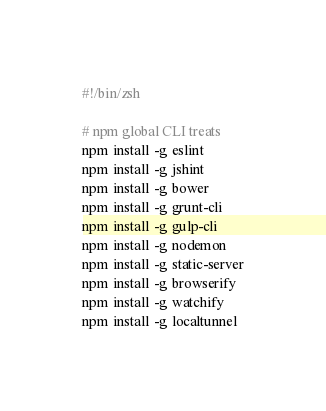Convert code to text. <code><loc_0><loc_0><loc_500><loc_500><_Bash_>#!/bin/zsh

# npm global CLI treats
npm install -g eslint
npm install -g jshint
npm install -g bower
npm install -g grunt-cli
npm install -g gulp-cli
npm install -g nodemon
npm install -g static-server
npm install -g browserify
npm install -g watchify
npm install -g localtunnel
</code> 